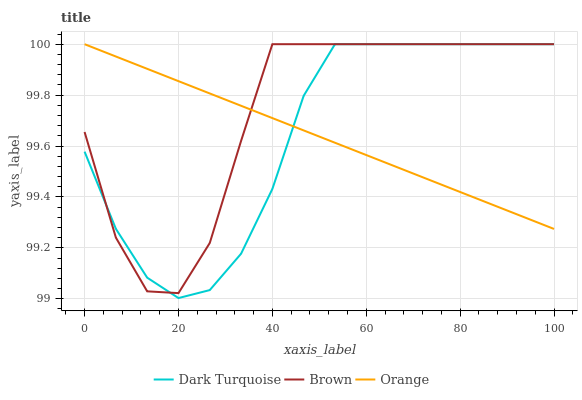Does Orange have the minimum area under the curve?
Answer yes or no. Yes. Does Brown have the maximum area under the curve?
Answer yes or no. Yes. Does Dark Turquoise have the minimum area under the curve?
Answer yes or no. No. Does Dark Turquoise have the maximum area under the curve?
Answer yes or no. No. Is Orange the smoothest?
Answer yes or no. Yes. Is Brown the roughest?
Answer yes or no. Yes. Is Dark Turquoise the smoothest?
Answer yes or no. No. Is Dark Turquoise the roughest?
Answer yes or no. No. Does Brown have the lowest value?
Answer yes or no. No. 